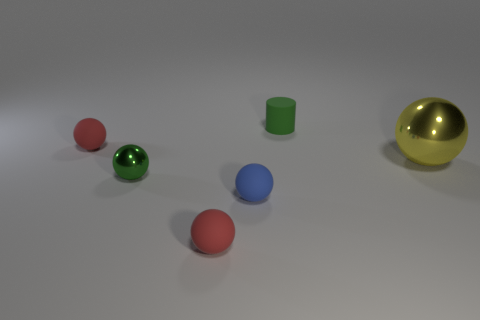There is a green ball that is the same size as the blue thing; what is it made of?
Your response must be concise. Metal. How many large yellow things are there?
Make the answer very short. 1. How big is the yellow metal object that is to the right of the tiny shiny object?
Make the answer very short. Large. Are there the same number of blue matte balls on the right side of the tiny cylinder and big blue spheres?
Ensure brevity in your answer.  Yes. Are there any large green shiny things of the same shape as the tiny blue matte object?
Offer a very short reply. No. What is the shape of the small rubber object that is both behind the tiny blue thing and left of the green matte cylinder?
Ensure brevity in your answer.  Sphere. Is the material of the tiny green sphere the same as the tiny red ball in front of the small blue rubber thing?
Make the answer very short. No. There is a small blue matte sphere; are there any small matte spheres in front of it?
Your answer should be compact. Yes. How many objects are tiny cylinders or things behind the big thing?
Keep it short and to the point. 2. There is a rubber ball right of the small red matte thing in front of the large object; what is its color?
Make the answer very short. Blue. 